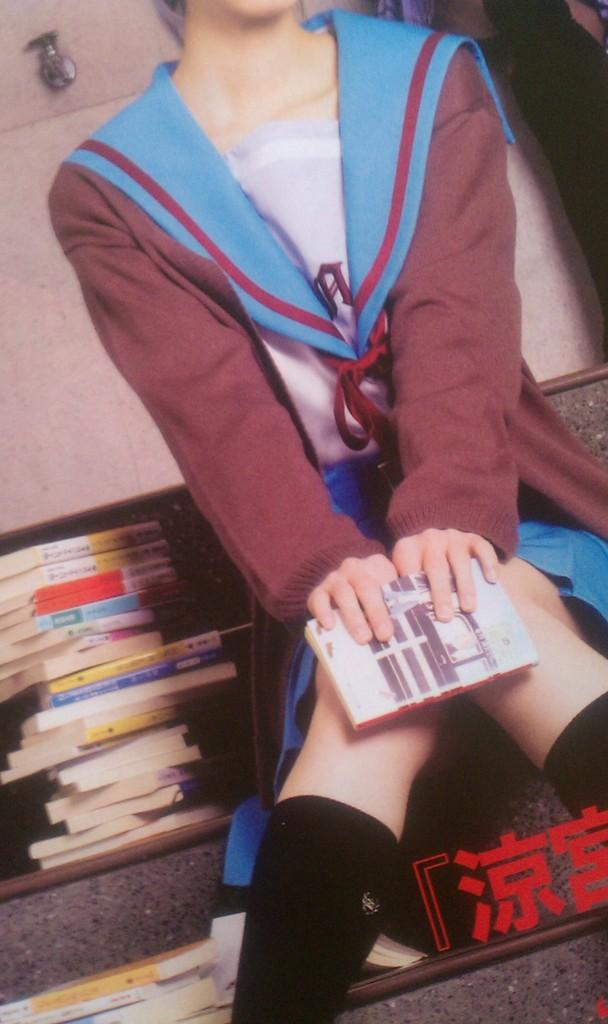What is the person in the image doing? The person is sitting in the image. What is the person holding in the image? The person is holding a book. Where are more books located in the image? There are books on the left side of the image. What type of cake is being served to the person in the image? There is no cake present in the image; the person is holding a book. 